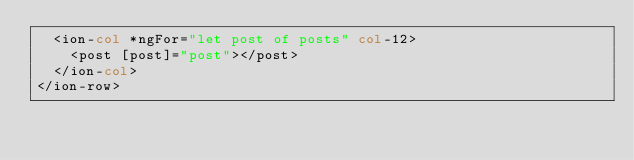<code> <loc_0><loc_0><loc_500><loc_500><_HTML_>  <ion-col *ngFor="let post of posts" col-12>
    <post [post]="post"></post>
  </ion-col>
</ion-row>
</code> 